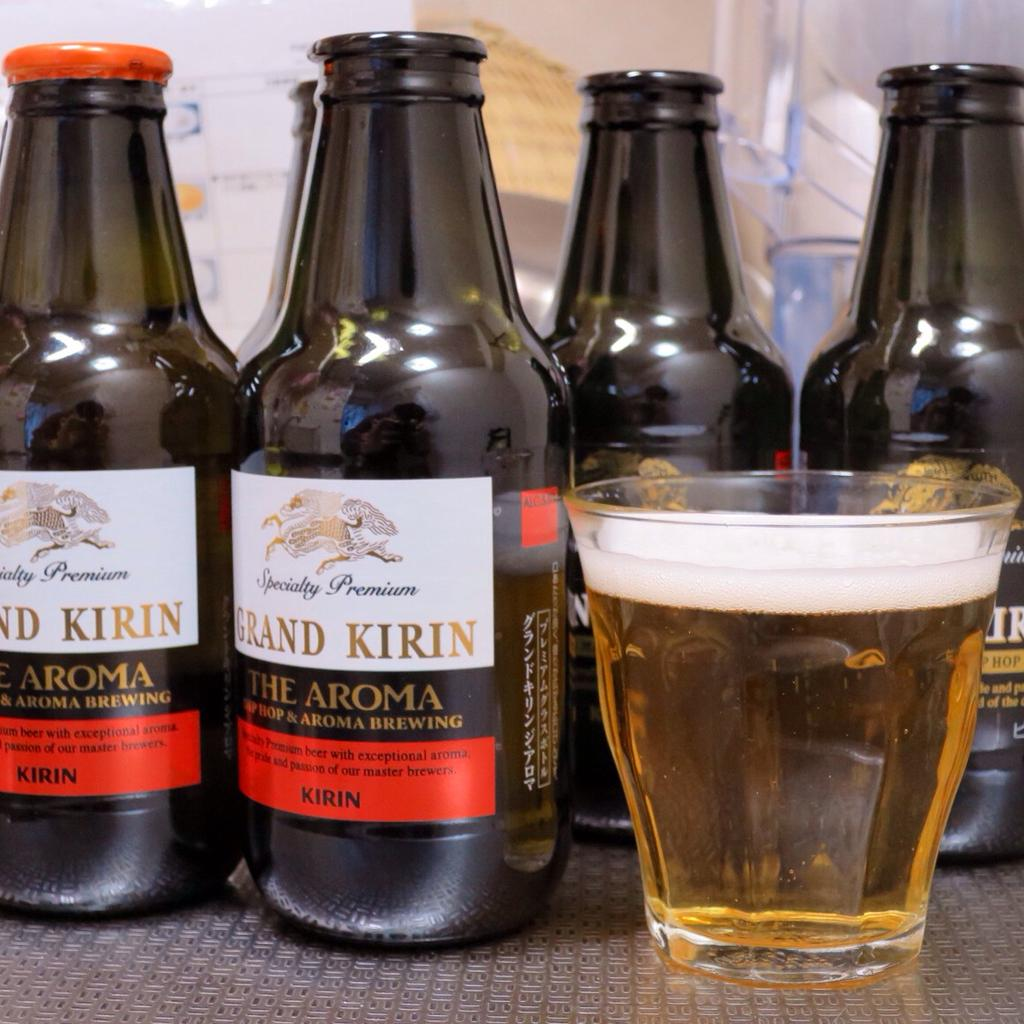<image>
Render a clear and concise summary of the photo. Several bottles of Grand Kirin, The Aroma, are sitting on a table and there is a glass containing the drink beside them. 